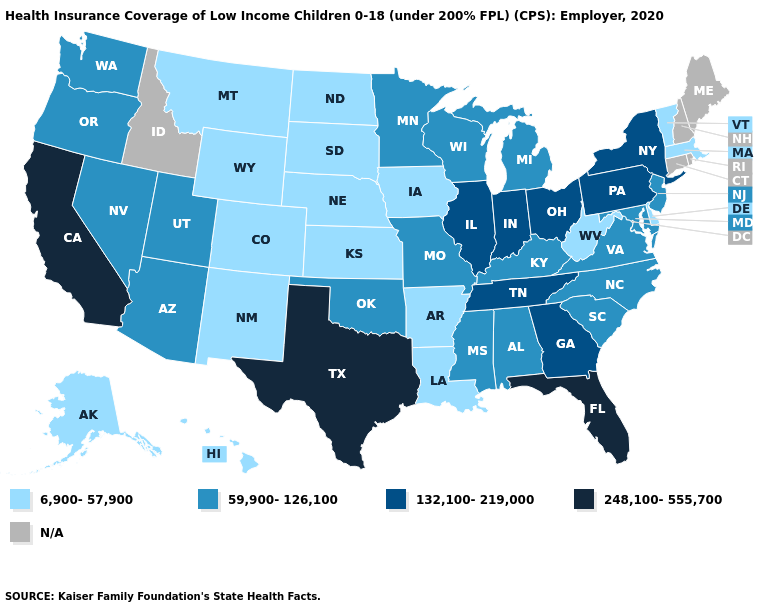Which states hav the highest value in the MidWest?
Answer briefly. Illinois, Indiana, Ohio. What is the lowest value in the USA?
Answer briefly. 6,900-57,900. Among the states that border Maryland , which have the lowest value?
Keep it brief. Delaware, West Virginia. What is the value of North Dakota?
Give a very brief answer. 6,900-57,900. Which states have the highest value in the USA?
Quick response, please. California, Florida, Texas. How many symbols are there in the legend?
Be succinct. 5. What is the value of Delaware?
Answer briefly. 6,900-57,900. What is the highest value in the USA?
Give a very brief answer. 248,100-555,700. How many symbols are there in the legend?
Write a very short answer. 5. What is the value of California?
Answer briefly. 248,100-555,700. What is the lowest value in states that border Tennessee?
Keep it brief. 6,900-57,900. Does Hawaii have the highest value in the USA?
Be succinct. No. What is the highest value in the USA?
Write a very short answer. 248,100-555,700. How many symbols are there in the legend?
Write a very short answer. 5. Is the legend a continuous bar?
Concise answer only. No. 